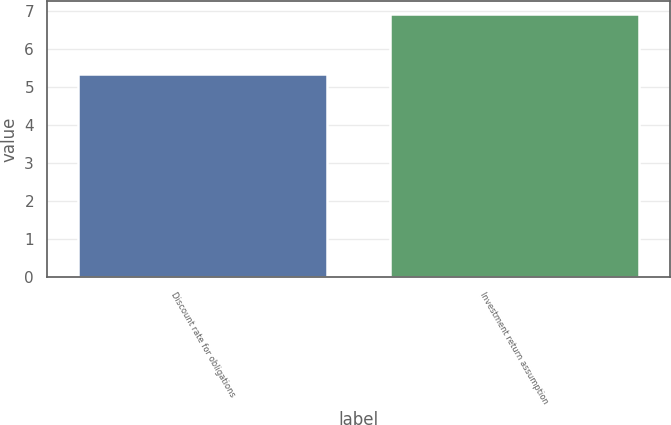<chart> <loc_0><loc_0><loc_500><loc_500><bar_chart><fcel>Discount rate for obligations<fcel>Investment return assumption<nl><fcel>5.34<fcel>6.93<nl></chart> 